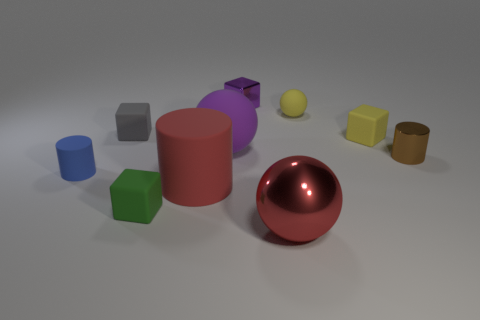What colors and shapes are represented in the objects in the image? The image displays a variety of colors and shapes. The colors include green, blue, red, yellow, brown, purple, and grey. As for shapes, there are cubes, cylinders, and a sphere. 